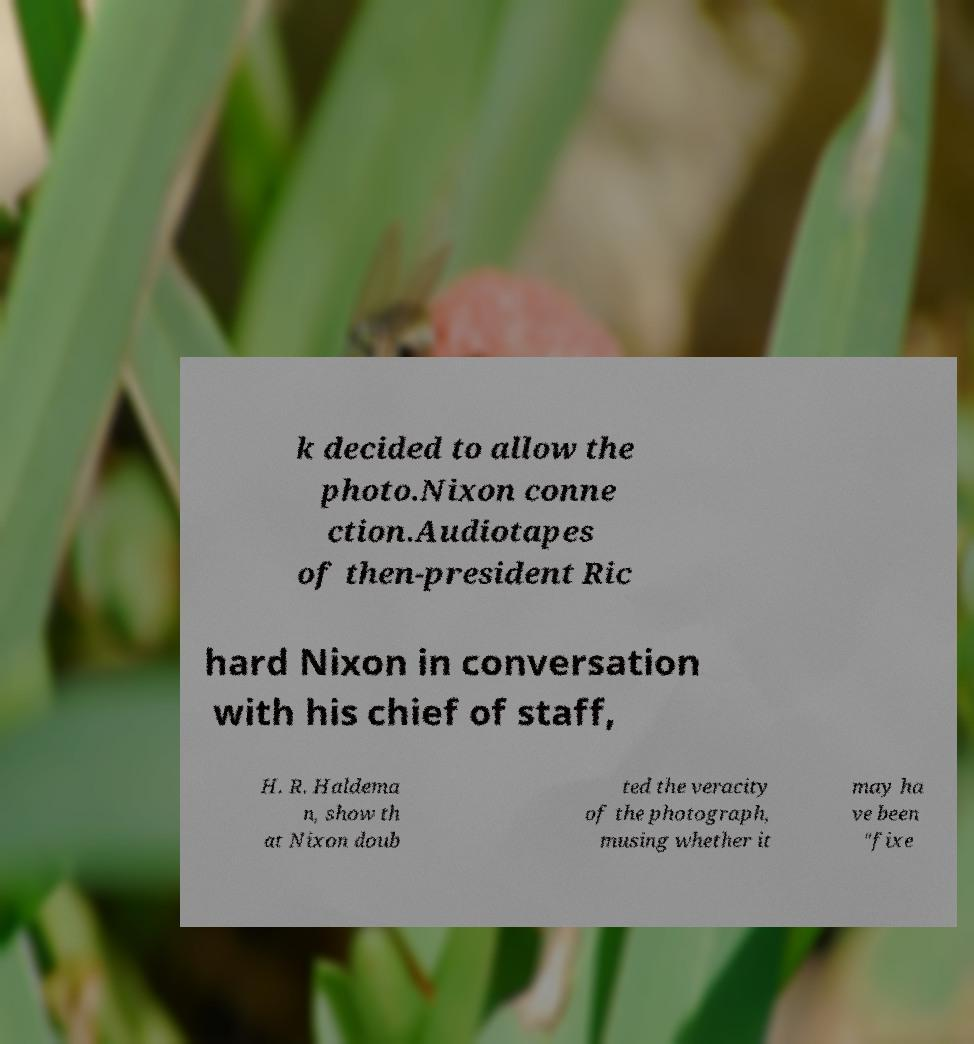There's text embedded in this image that I need extracted. Can you transcribe it verbatim? k decided to allow the photo.Nixon conne ction.Audiotapes of then-president Ric hard Nixon in conversation with his chief of staff, H. R. Haldema n, show th at Nixon doub ted the veracity of the photograph, musing whether it may ha ve been "fixe 